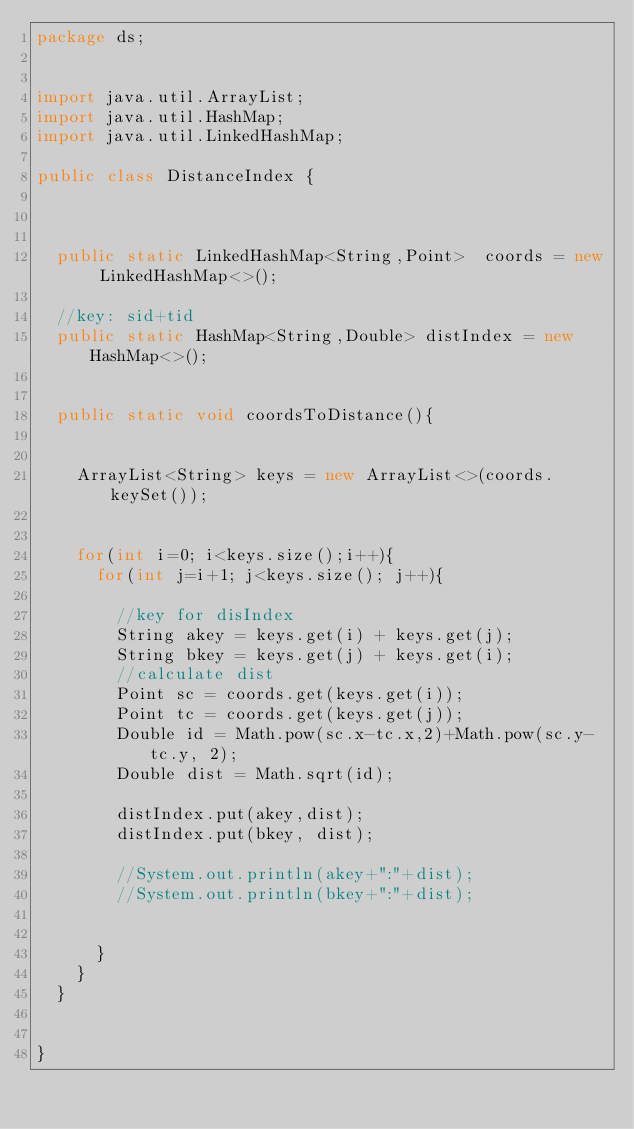Convert code to text. <code><loc_0><loc_0><loc_500><loc_500><_Java_>package ds;


import java.util.ArrayList;
import java.util.HashMap;
import java.util.LinkedHashMap;

public class DistanceIndex {

	
	
	public static LinkedHashMap<String,Point>  coords = new LinkedHashMap<>();
	
	//key: sid+tid
	public static HashMap<String,Double> distIndex = new HashMap<>();
	
	
	public static void coordsToDistance(){
		
		
		ArrayList<String> keys = new ArrayList<>(coords.keySet());
		
		
		for(int i=0; i<keys.size();i++){
			for(int j=i+1; j<keys.size(); j++){
				
				//key for disIndex
				String akey = keys.get(i) + keys.get(j);
				String bkey = keys.get(j) + keys.get(i);
				//calculate dist
				Point sc = coords.get(keys.get(i));
				Point tc = coords.get(keys.get(j));
				Double id = Math.pow(sc.x-tc.x,2)+Math.pow(sc.y-tc.y, 2);
				Double dist = Math.sqrt(id);
				
				distIndex.put(akey,dist);
				distIndex.put(bkey, dist);
				
				//System.out.println(akey+":"+dist);
				//System.out.println(bkey+":"+dist);
				
				
			}
		}
	}

	
}
</code> 